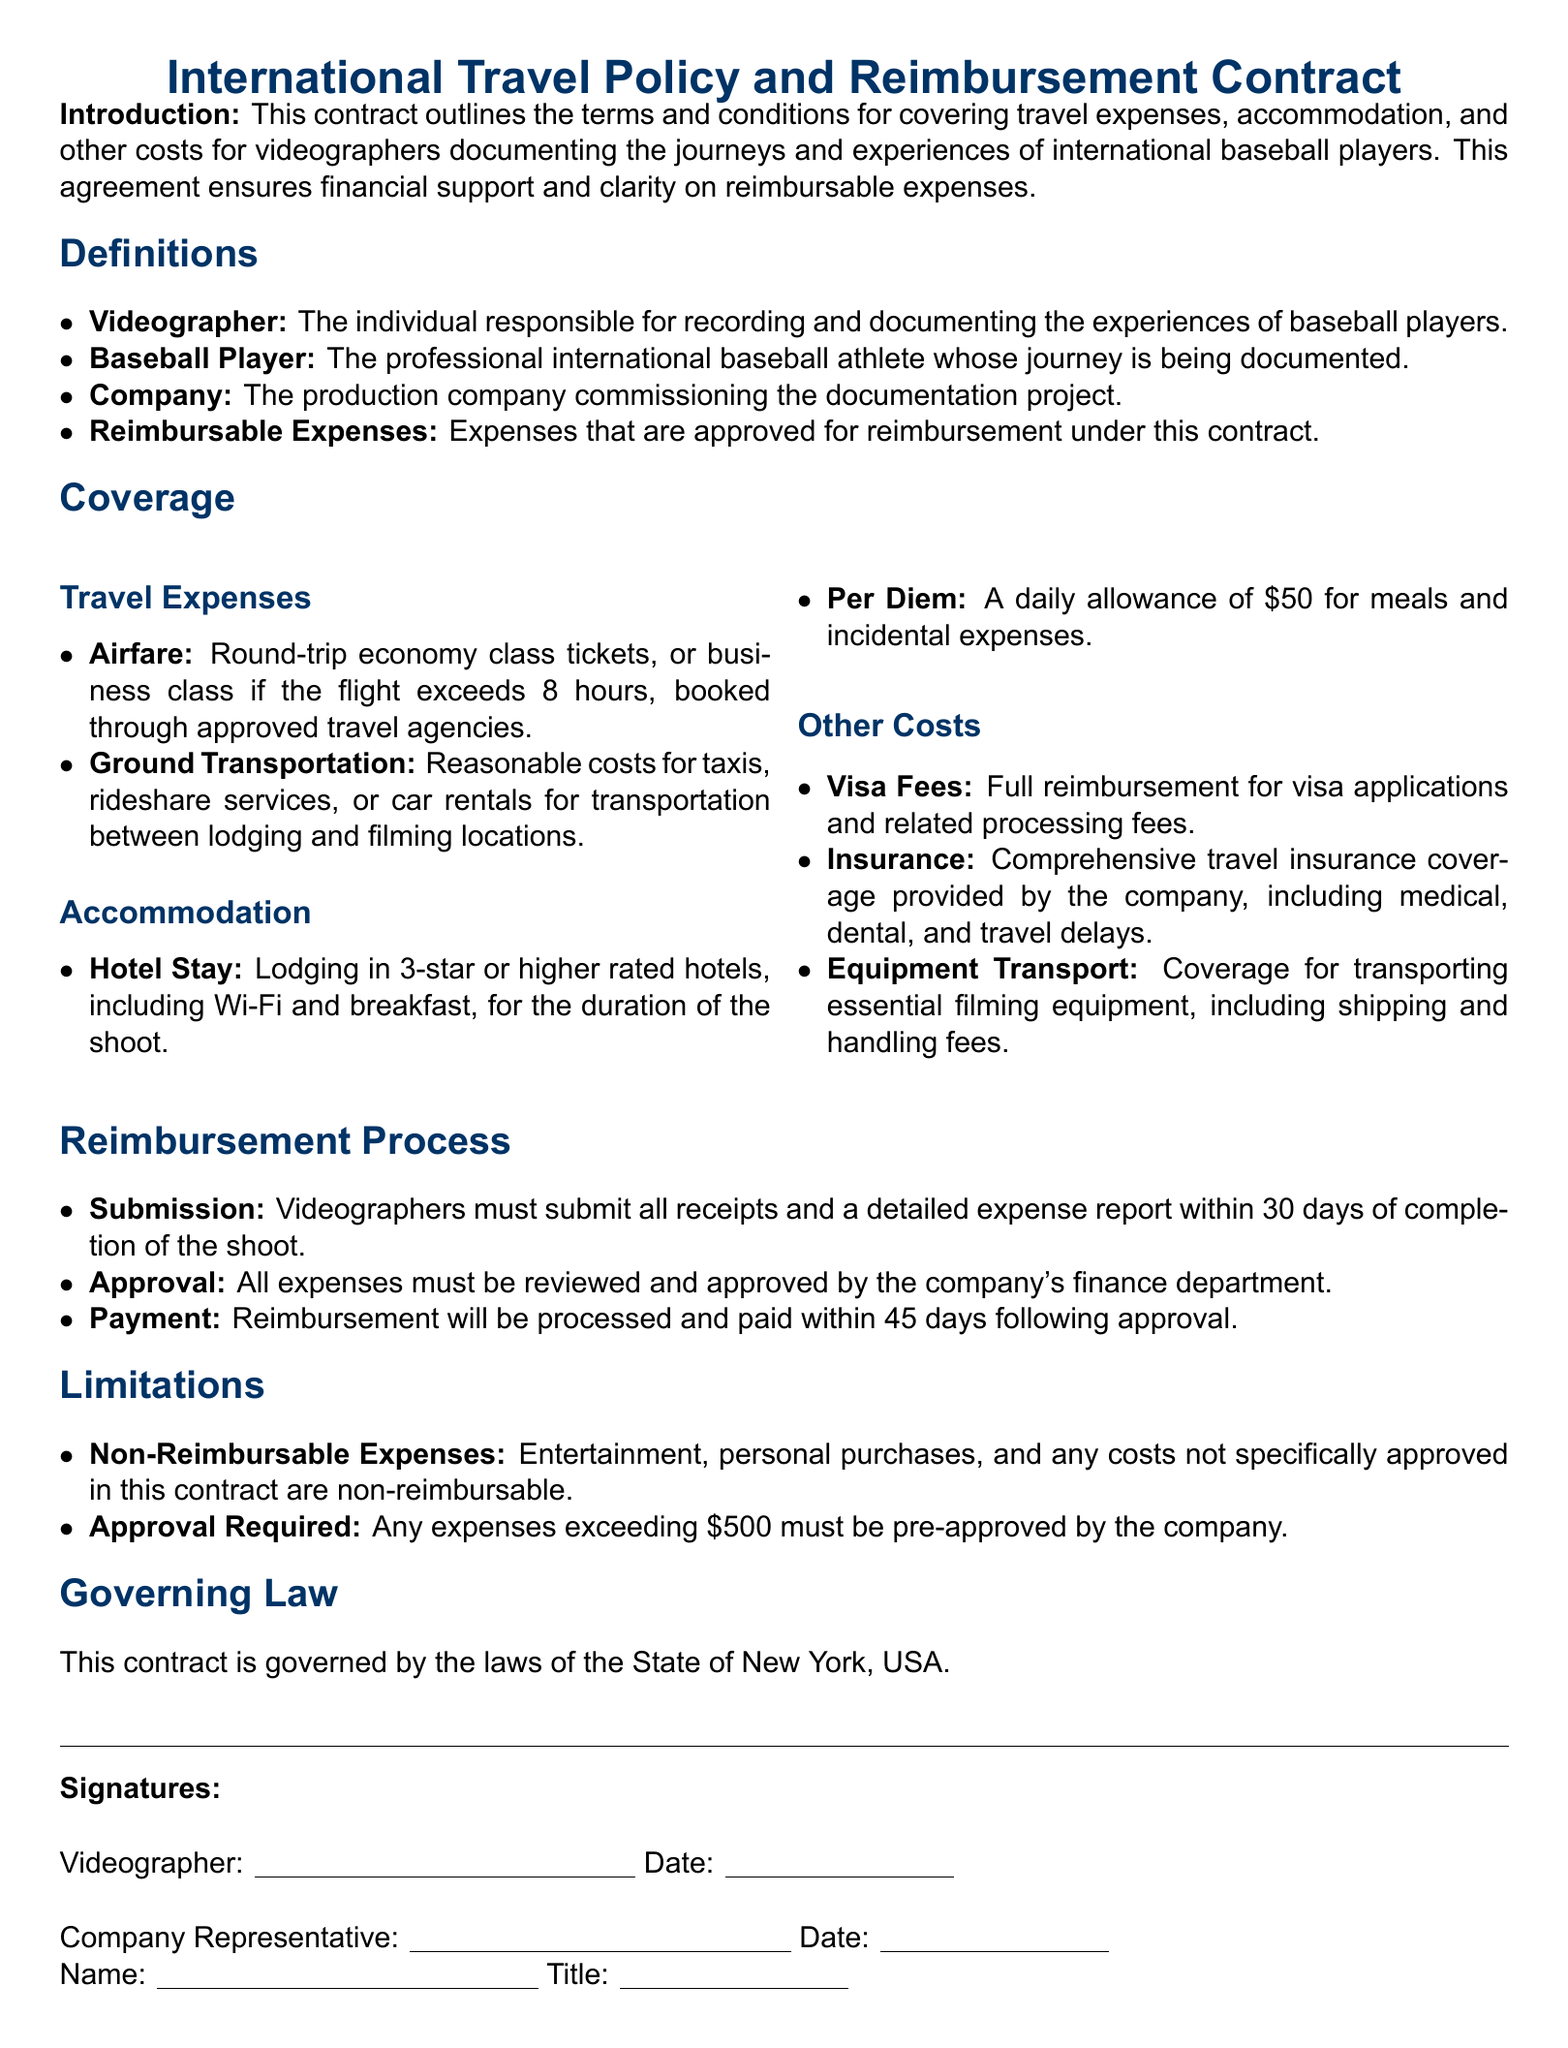What is the title of the document? The title of the document is provided at the beginning, which is "International Travel Policy and Reimbursement Contract."
Answer: International Travel Policy and Reimbursement Contract What is the daily per diem amount for meals? The per diem amount specified for meals and incidental expenses is mentioned in the accommodation section of the document as \$50.
Answer: $50 What type of hotel stay is covered? The document specifies that lodging in 3-star or higher rated hotels is covered during the shoot.
Answer: 3-star or higher rated hotels What is the reimbursement deadline for submitting receipts? The document states that videographers must submit receipts within 30 days of the shoot's completion for reimbursement.
Answer: 30 days Which department approves the expenses? The document mentions that expenses must be reviewed and approved by the company's finance department.
Answer: Finance department What is the maximum amount for expenses that requires pre-approval? The document specifies that any expenses exceeding \$500 must be pre-approved by the company.
Answer: $500 What is the reimbursement processing time after approval? The document states that reimbursement will be processed and paid within 45 days following approval.
Answer: 45 days What types of costs are considered non-reimbursable? The document lists entertainment and personal purchases as examples of non-reimbursable expenses.
Answer: Entertainment, personal purchases What law governs this contract? The governing law for this contract is stated in the document as the laws of the State of New York, USA.
Answer: Laws of the State of New York, USA 